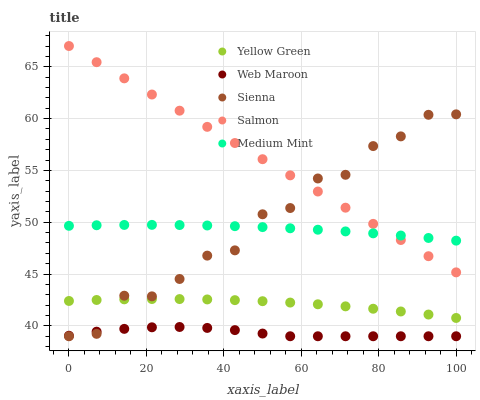Does Web Maroon have the minimum area under the curve?
Answer yes or no. Yes. Does Salmon have the maximum area under the curve?
Answer yes or no. Yes. Does Salmon have the minimum area under the curve?
Answer yes or no. No. Does Web Maroon have the maximum area under the curve?
Answer yes or no. No. Is Salmon the smoothest?
Answer yes or no. Yes. Is Sienna the roughest?
Answer yes or no. Yes. Is Web Maroon the smoothest?
Answer yes or no. No. Is Web Maroon the roughest?
Answer yes or no. No. Does Sienna have the lowest value?
Answer yes or no. Yes. Does Salmon have the lowest value?
Answer yes or no. No. Does Salmon have the highest value?
Answer yes or no. Yes. Does Web Maroon have the highest value?
Answer yes or no. No. Is Web Maroon less than Yellow Green?
Answer yes or no. Yes. Is Salmon greater than Yellow Green?
Answer yes or no. Yes. Does Medium Mint intersect Sienna?
Answer yes or no. Yes. Is Medium Mint less than Sienna?
Answer yes or no. No. Is Medium Mint greater than Sienna?
Answer yes or no. No. Does Web Maroon intersect Yellow Green?
Answer yes or no. No. 